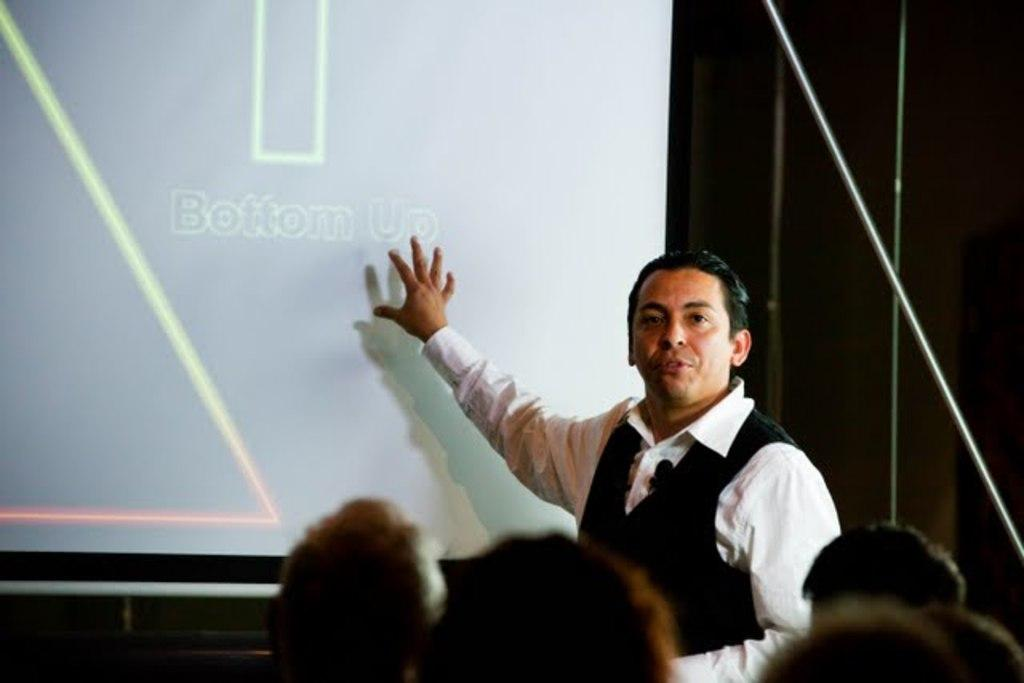What are the people in the image doing? The people in the image are sitting on chairs. Is there anyone standing in the image? Yes, there is a person standing on the floor in the image. What can be seen on the display screen in the image? The facts provided do not specify what is on the display screen. How many crows are sitting on the chairs in the image? There are no crows present in the image; it features people sitting on chairs and a person standing on the floor. 